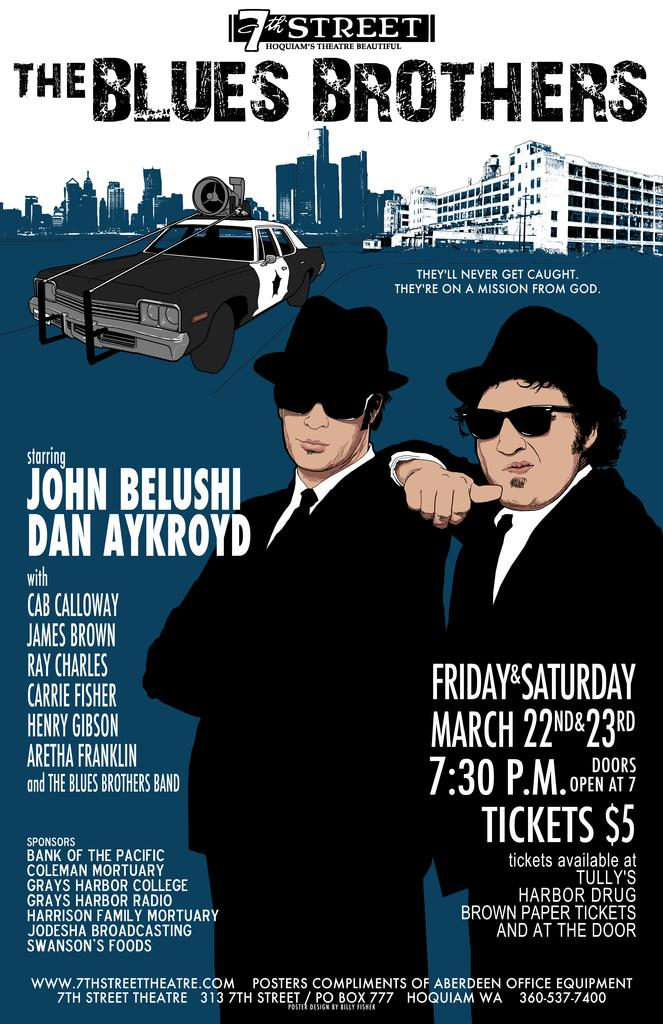What is the main subject of the poster in the image? The poster features two persons. Are there any vehicles depicted on the poster? Yes, the poster includes a car. What type of structures can be seen on the poster? The poster has buildings depicted. What else is present on the poster besides the images? There are letters and numbers on the poster. What type of farm equipment can be seen in the image? There is no farm equipment present in the image; it features a poster with two persons, a car, buildings, letters, and numbers. 